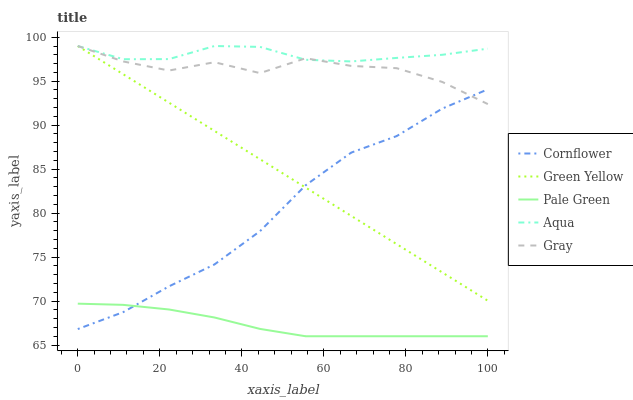Does Pale Green have the minimum area under the curve?
Answer yes or no. Yes. Does Aqua have the maximum area under the curve?
Answer yes or no. Yes. Does Green Yellow have the minimum area under the curve?
Answer yes or no. No. Does Green Yellow have the maximum area under the curve?
Answer yes or no. No. Is Green Yellow the smoothest?
Answer yes or no. Yes. Is Gray the roughest?
Answer yes or no. Yes. Is Pale Green the smoothest?
Answer yes or no. No. Is Pale Green the roughest?
Answer yes or no. No. Does Pale Green have the lowest value?
Answer yes or no. Yes. Does Green Yellow have the lowest value?
Answer yes or no. No. Does Gray have the highest value?
Answer yes or no. Yes. Does Pale Green have the highest value?
Answer yes or no. No. Is Cornflower less than Aqua?
Answer yes or no. Yes. Is Green Yellow greater than Pale Green?
Answer yes or no. Yes. Does Green Yellow intersect Cornflower?
Answer yes or no. Yes. Is Green Yellow less than Cornflower?
Answer yes or no. No. Is Green Yellow greater than Cornflower?
Answer yes or no. No. Does Cornflower intersect Aqua?
Answer yes or no. No. 